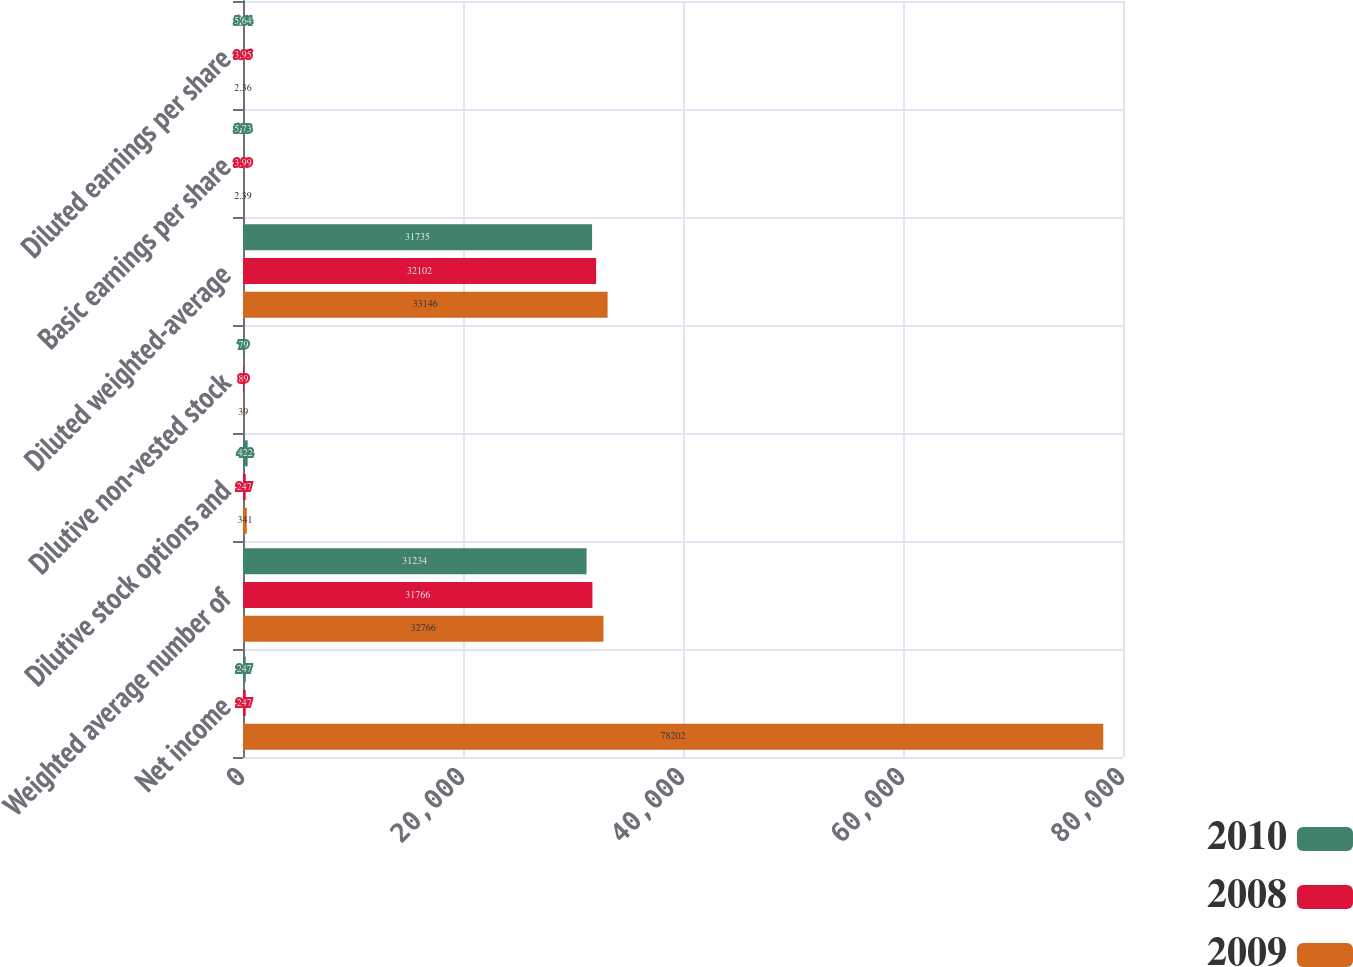<chart> <loc_0><loc_0><loc_500><loc_500><stacked_bar_chart><ecel><fcel>Net income<fcel>Weighted average number of<fcel>Dilutive stock options and<fcel>Dilutive non-vested stock<fcel>Diluted weighted-average<fcel>Basic earnings per share<fcel>Diluted earnings per share<nl><fcel>2010<fcel>247<fcel>31234<fcel>422<fcel>79<fcel>31735<fcel>5.73<fcel>5.64<nl><fcel>2008<fcel>247<fcel>31766<fcel>247<fcel>89<fcel>32102<fcel>3.99<fcel>3.95<nl><fcel>2009<fcel>78202<fcel>32766<fcel>341<fcel>39<fcel>33146<fcel>2.39<fcel>2.36<nl></chart> 